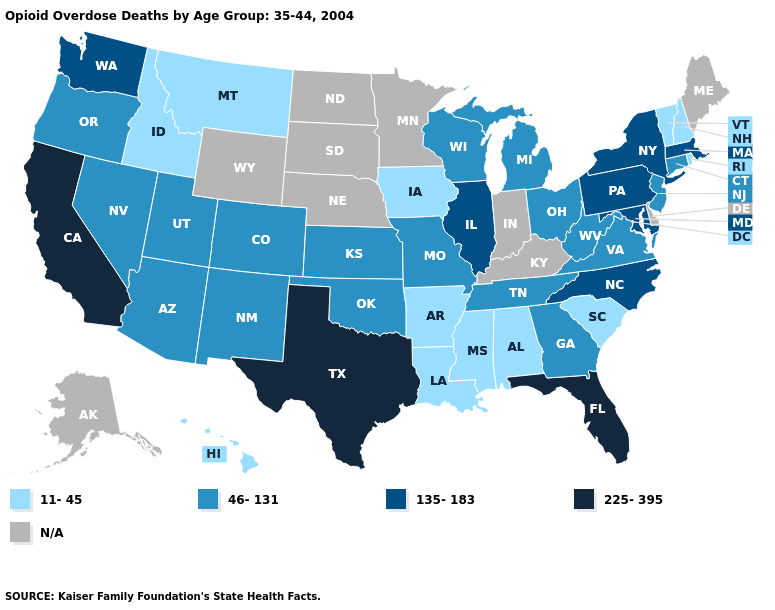Name the states that have a value in the range N/A?
Give a very brief answer. Alaska, Delaware, Indiana, Kentucky, Maine, Minnesota, Nebraska, North Dakota, South Dakota, Wyoming. Among the states that border Alabama , which have the highest value?
Concise answer only. Florida. What is the value of Florida?
Keep it brief. 225-395. What is the highest value in the USA?
Write a very short answer. 225-395. Does Pennsylvania have the lowest value in the USA?
Keep it brief. No. Among the states that border Connecticut , which have the highest value?
Concise answer only. Massachusetts, New York. What is the value of New Hampshire?
Concise answer only. 11-45. Which states have the lowest value in the USA?
Concise answer only. Alabama, Arkansas, Hawaii, Idaho, Iowa, Louisiana, Mississippi, Montana, New Hampshire, Rhode Island, South Carolina, Vermont. Which states have the lowest value in the Northeast?
Concise answer only. New Hampshire, Rhode Island, Vermont. What is the value of West Virginia?
Keep it brief. 46-131. Name the states that have a value in the range 135-183?
Give a very brief answer. Illinois, Maryland, Massachusetts, New York, North Carolina, Pennsylvania, Washington. Name the states that have a value in the range 135-183?
Quick response, please. Illinois, Maryland, Massachusetts, New York, North Carolina, Pennsylvania, Washington. Which states have the highest value in the USA?
Give a very brief answer. California, Florida, Texas. Which states have the highest value in the USA?
Quick response, please. California, Florida, Texas. 